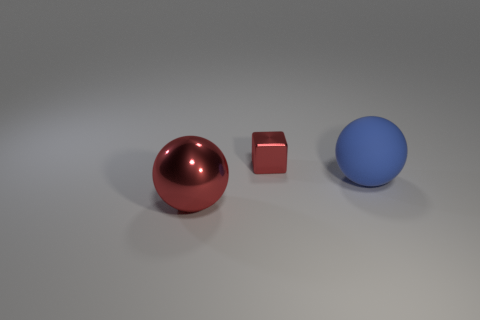Add 3 big purple balls. How many objects exist? 6 Subtract all red spheres. How many spheres are left? 1 Subtract 1 cubes. How many cubes are left? 0 Subtract all cyan spheres. Subtract all brown cubes. How many spheres are left? 2 Subtract all yellow cubes. How many blue spheres are left? 1 Subtract all large purple balls. Subtract all metallic objects. How many objects are left? 1 Add 1 tiny shiny objects. How many tiny shiny objects are left? 2 Add 3 large red metal spheres. How many large red metal spheres exist? 4 Subtract 0 gray cylinders. How many objects are left? 3 Subtract all cubes. How many objects are left? 2 